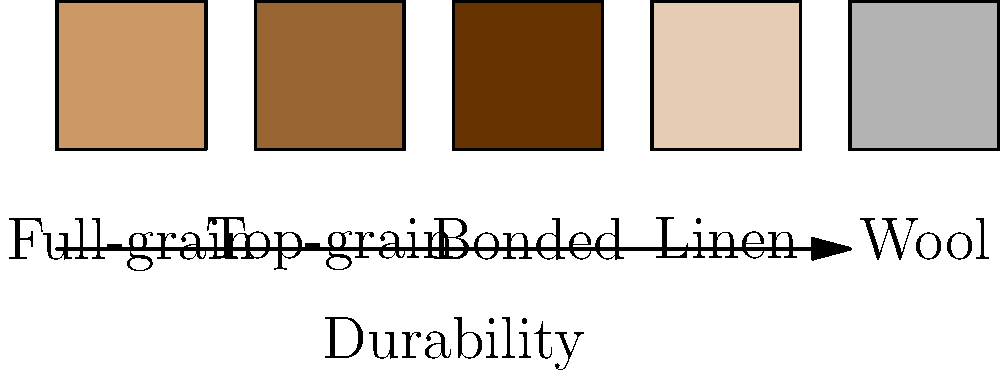When combining leather with other materials in an interior design project, which pairing would create the most durable and long-lasting result? To determine the most durable pairing, we need to consider the characteristics of each material:

1. Full-grain leather: The highest quality and most durable type of leather, retaining the entire grain.
2. Top-grain leather: Second-highest quality, slightly less durable than full-grain but still very strong.
3. Bonded leather: Least durable of the leather types shown, made from leather scraps.
4. Linen: A strong natural fiber, but less durable than high-quality leather.
5. Wool: Naturally resilient and durable, but can wear down faster than high-quality leather.

Steps to determine the most durable pairing:
1. Identify the most durable leather: Full-grain leather
2. Compare full-grain leather with other materials:
   - Full-grain leather is more durable than linen and wool
   - Full-grain leather is more durable than top-grain and bonded leather
3. Consider complementary properties:
   - Wool has natural resilience and can enhance overall durability
   - Wool's texture contrasts well with leather, creating visual interest

Conclusion: Pairing full-grain leather with wool would create the most durable and long-lasting result while also providing an interesting textural contrast.
Answer: Full-grain leather and wool 